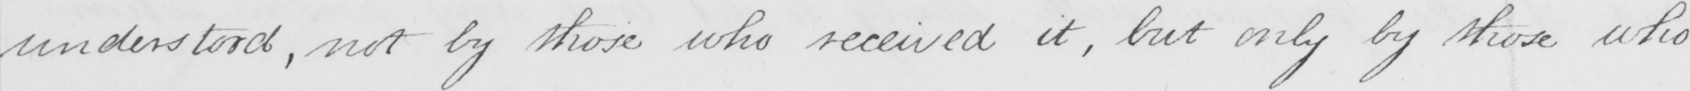What text is written in this handwritten line? understood , not by those who received it , but only by those who 